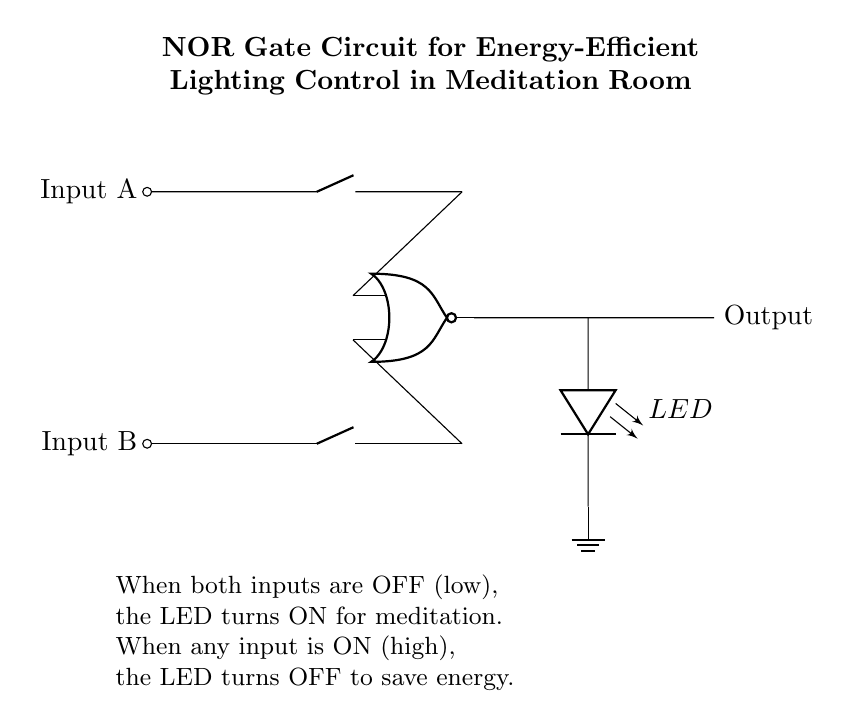What is the function of the NOR gate in this circuit? The NOR gate outputs a high signal only when both its inputs are low. This is essential for controlling the LED in a way that it turns on for meditation when there is no input.
Answer: Turning on the LED What do the inputs A and B represent in this circuit? Inputs A and B represent the state of the lighting control. If either input is high (on), the circuit will turn off the LED to save energy.
Answer: Lighting control states What happens to the LED output when both inputs are high? When both inputs are high, the NOR gate outputs a low signal, which turns off the LED. This configuration is designed to save energy during meditation.
Answer: LED turns off How many LEDs are present in this circuit? The circuit diagram clearly shows one LED connected to the output of the NOR gate.
Answer: One LED What is the purpose of the ground connection in this circuit? The ground connection provides a reference point for the circuit and completes the electrical path. It ensures the circuit operates correctly by establishing a zero-voltage level.
Answer: To complete the circuit If only input A is high, what will be the output? With only input A high, the NOR gate receives one high and one low input, resulting in a low output which turns off the LED. This conserves energy when the lighting is controlling.
Answer: LED turns off What state is the LED in when both inputs are low? When both inputs are low, the output from the NOR gate is high, allowing the LED to turn on and provide light for the meditation room.
Answer: LED turns on 